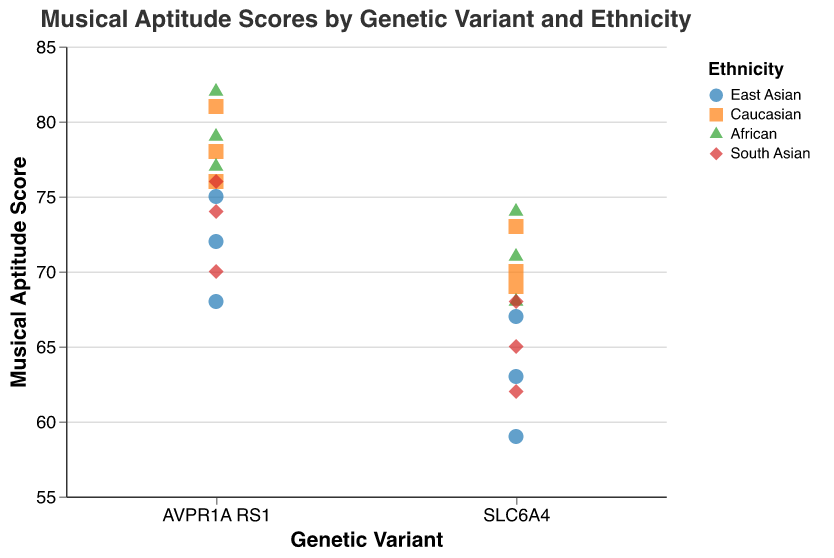What is the title of the figure? The title is typically displayed at the top of the figure, and in this case, it is "Musical Aptitude Scores by Genetic Variant and Ethnicity."
Answer: Musical Aptitude Scores by Genetic Variant and Ethnicity Which ethnicity has the highest musical aptitude score for the AVPR1A RS1 genetic variant? Looking at the strip plot, the highest score for the AVPR1A RS1 variant is among the African ethnicity, which has a score of 82.
Answer: African What is the range of musical aptitude scores for the SLC6A4 genetic variant across all ethnicities? The range is found by identifying the minimum and maximum scores for the SLC6A4 variant. The minimum score is 59, and the maximum score is 74, giving us a range of 15.
Answer: 59 to 74 How many data points are there in total for the Caucasian ethnicity? By counting the points in the plot that are color-coded for the Caucasian ethnicity, there are 6 data points.
Answer: 6 Which genetic variant shows the highest overall musical aptitude scores across all ethnicities? By observing the plot, the highest scores are associated with the AVPR1A RS1 genetic variant, particularly in the African and Caucasian ethnicities, reaching up to 82 and 81, respectively.
Answer: AVPR1A RS1 Which ethnicity has the lowest musical aptitude score for the SLC6A4 genetic variant? The lowest score for the SLC6A4 variant is found among the East Asian group, which has a score of 59.
Answer: East Asian Compare the average musical aptitude score of the AVPR1A RS1 variant between the East Asian and Caucasian ethnicities. Which one is higher? Calculate the average for East Asian (72+68+75)/3 = 71.67 and for Caucasian (78+81+76)/3 = 78.33. Caucasian has the higher average score.
Answer: Caucasian What shape represents the African ethnicity in the strip plot? The shapes representing each ethnicity are distinct. In this case, the African ethnicity is represented by triangles.
Answer: Triangle Is the musical aptitude score distribution for the South Asian ethnicity for the AVPR1A RS1 variant wider or narrower compared to the SLC6A4 variant? By observing the spread of points, AVPR1A RS1 scores range from 70 to 76, while SLC6A4 ranges from 62 to 68. The AVPR1A RS1 variant has a wider distribution (6 vs. 3).
Answer: Wider What is the primary color used to represent the Caucasian ethnicity in the plot? The color associated with Caucasian ethnicity in the color legend is orange.
Answer: Orange 